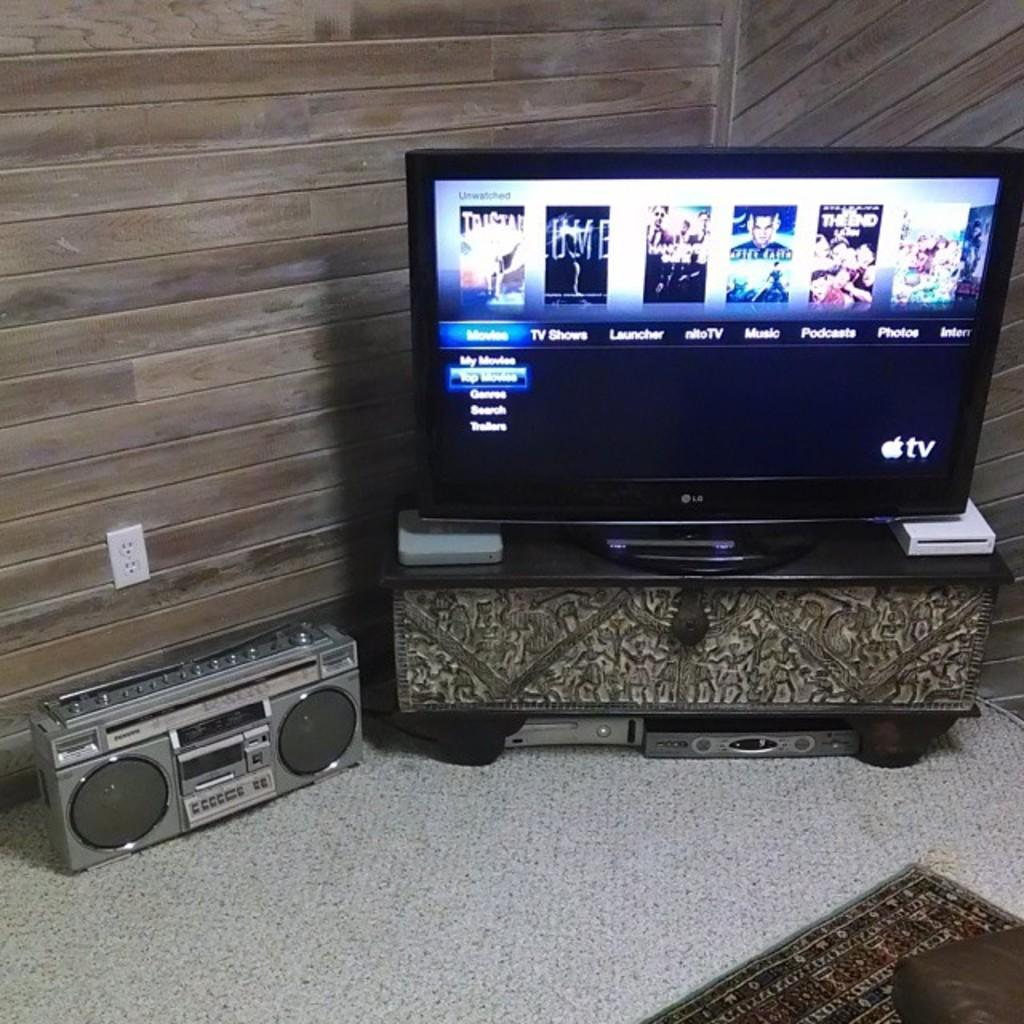Provide a one-sentence caption for the provided image. A wide screen television displays an Apple TV menu page. 